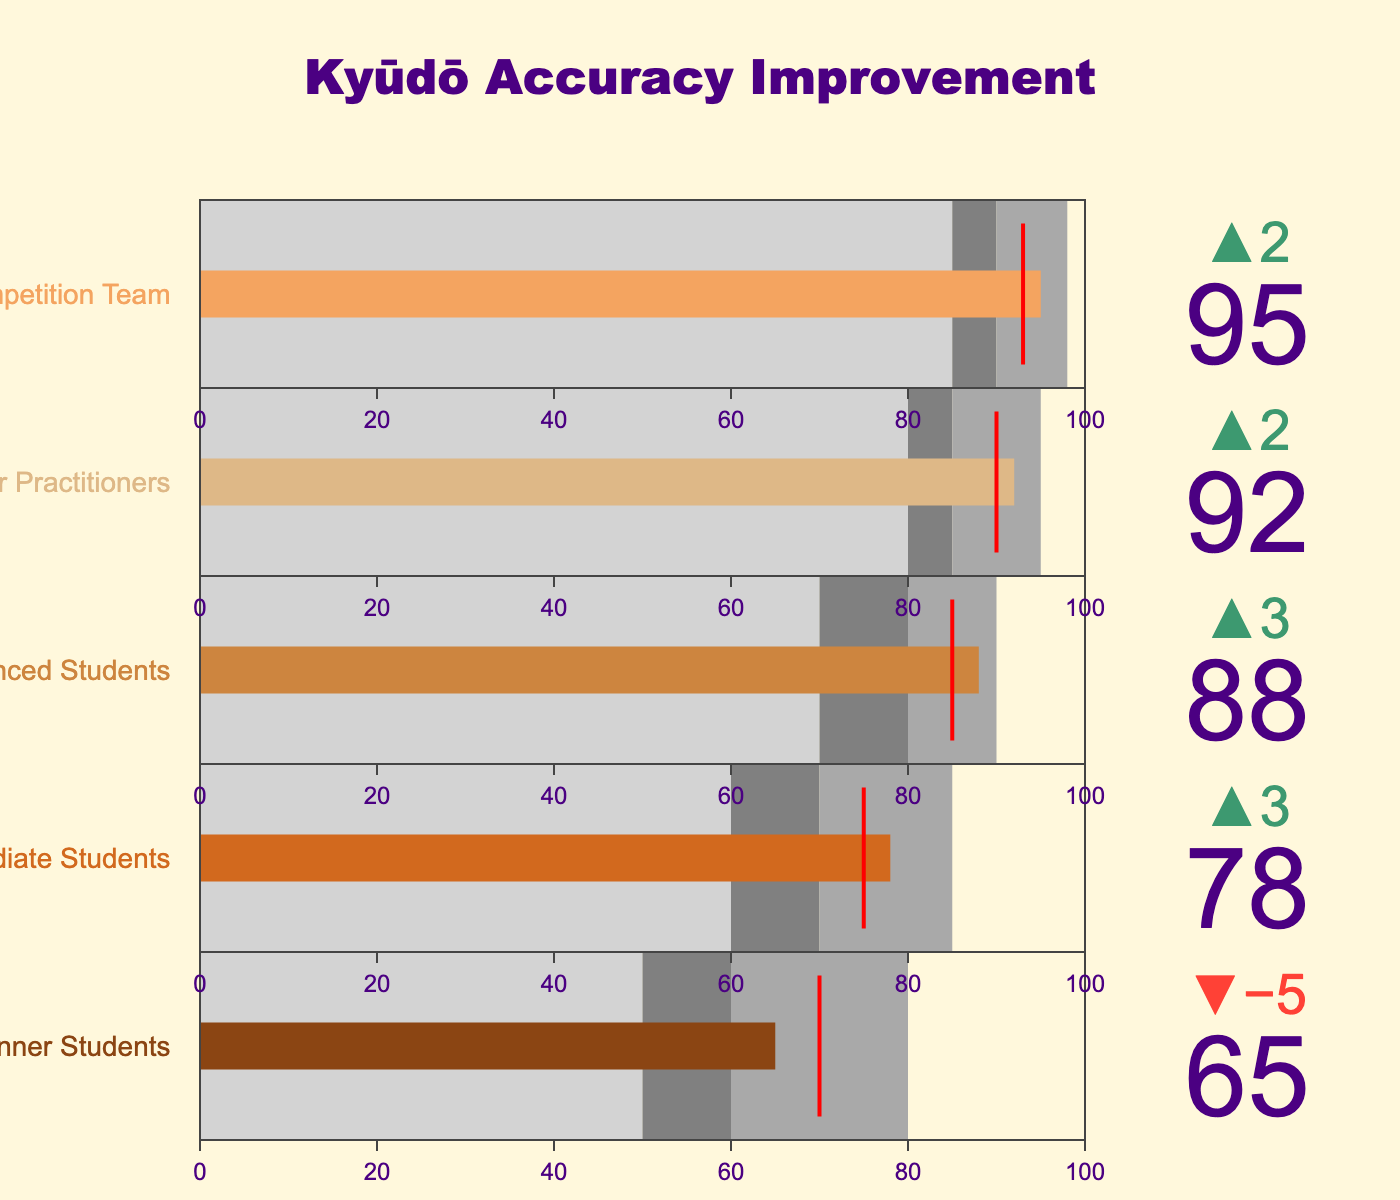What's the title of the figure? The title is displayed prominently at the top of the figure. It reads "Kyūdō Accuracy Improvement".
Answer: Kyūdō Accuracy Improvement How many categories of students are displayed in the figure? By examining the titles of each bullet chart, we can see there are five categories: Beginner Students, Intermediate Students, Advanced Students, Senior Practitioners, and Competition Team.
Answer: 5 What is the accuracy goal for Advanced Students? The goal values are represented by red lines and are also labeled. The goal for Advanced Students is indicated by the red line at 85.
Answer: 85 What range represents "Good" performance for Senior Practitioners? The range indications are labeled in different shades of gray. For Senior Practitioners, the "Good" range is between 85 and 90.
Answer: 85 to 90 Which category exceeded its accuracy goal by the largest margin? By how much? To find this, we check the delta values (difference between actual and goal). The Competition Team exceeded its goal by the largest margin: 95 (actual) - 93 (goal) = 2.
Answer: Competition Team by 2 Which category has the lowest actual accuracy value? By examining the actual values listed for each category, we see that Beginner Students have the lowest accuracy with a value of 65.
Answer: Beginner Students Compare the actual accuracy of Intermediate Students and Advanced Students. Which is higher and by how much? Looking at the actual values, Intermediate Students have an actual accuracy of 78 while Advanced Students have 88. The difference is 88 - 78 = 10.
Answer: Advanced Students by 10 What is the average accuracy goal across all categories? To find the average accuracy goal, sum all the goal values and divide by the number of categories: (70 + 75 + 85 + 90 + 93) / 5 = 413 / 5 = 82.6.
Answer: 82.6 For which category does the actual accuracy match the "Excellent" range exactly? The "Excellent" range indicates the highest performance level. Looking at Senior Practitioners, their actual accuracy is 92, which matches the beginning of the "Excellent" range (90 to 95).
Answer: Senior Practitioners What color represents the "Satisfactory" performance range for Intermediate Students? The bullet chart uses color-coding to represent performance ranges. For Intermediate Students, "Satisfactory" is represented by light gray.
Answer: Light gray 